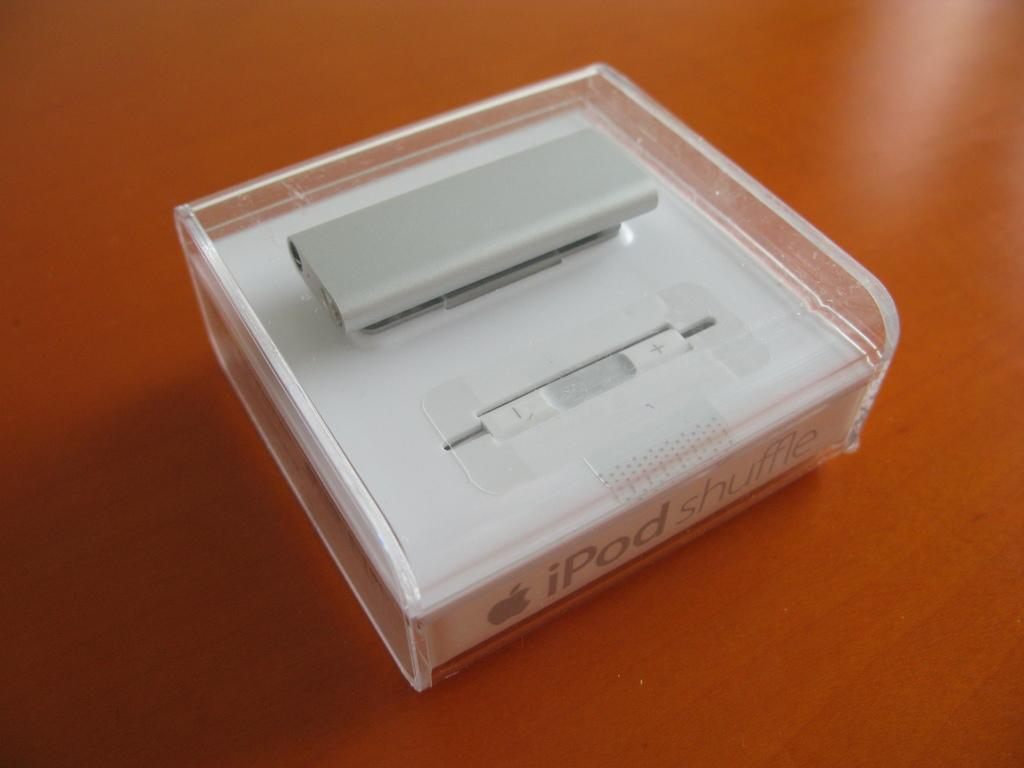<image>
Give a short and clear explanation of the subsequent image. A plastic box with the words ipod Shuffle on the bottom 